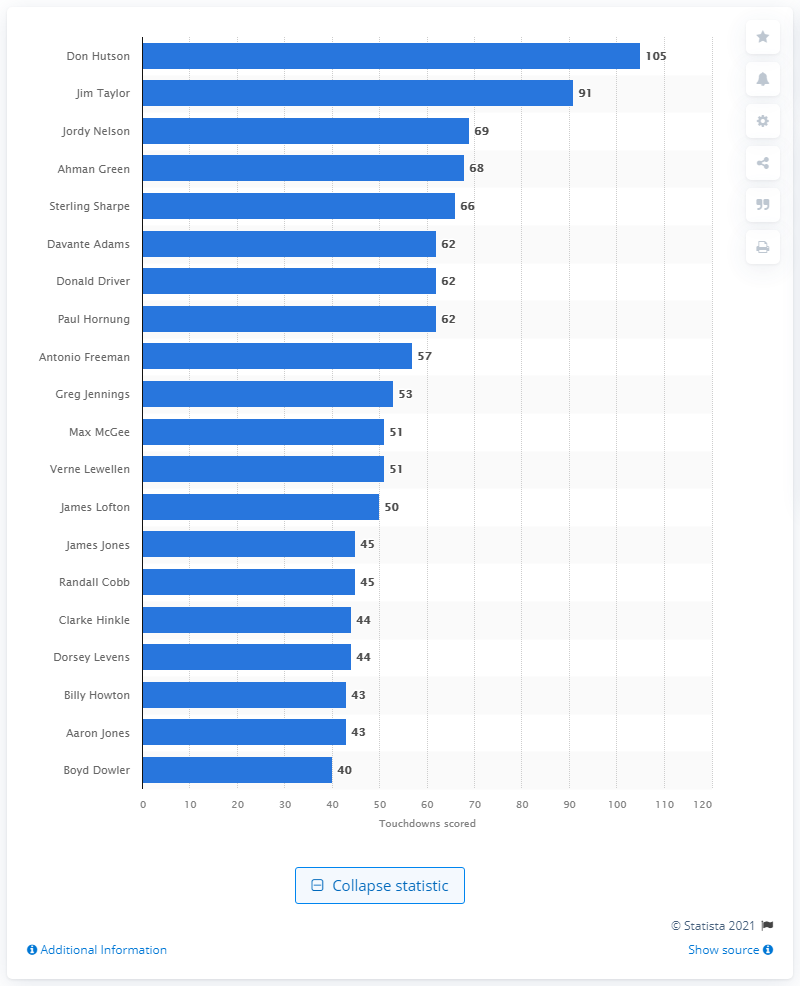Outline some significant characteristics in this image. Don Hutson is the career touchdown leader of the Green Bay Packers. Don Hutson, a former Green Bay Packers player, scored a total of 105 career touchdowns for the team. 